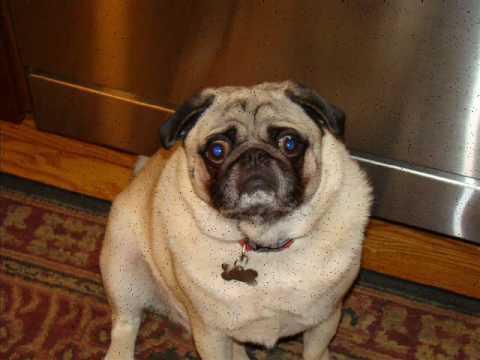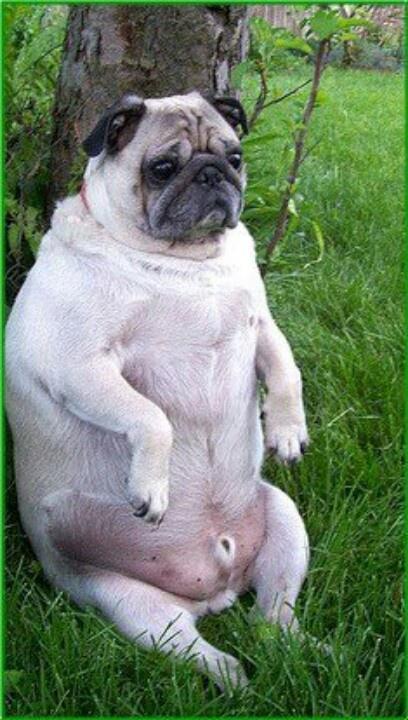The first image is the image on the left, the second image is the image on the right. Evaluate the accuracy of this statement regarding the images: "One dog has its front paws off the ground.". Is it true? Answer yes or no. Yes. The first image is the image on the left, the second image is the image on the right. Given the left and right images, does the statement "Each image shows one fat beige pug in a sitting pose, and no pugs are wearing outfits." hold true? Answer yes or no. Yes. 